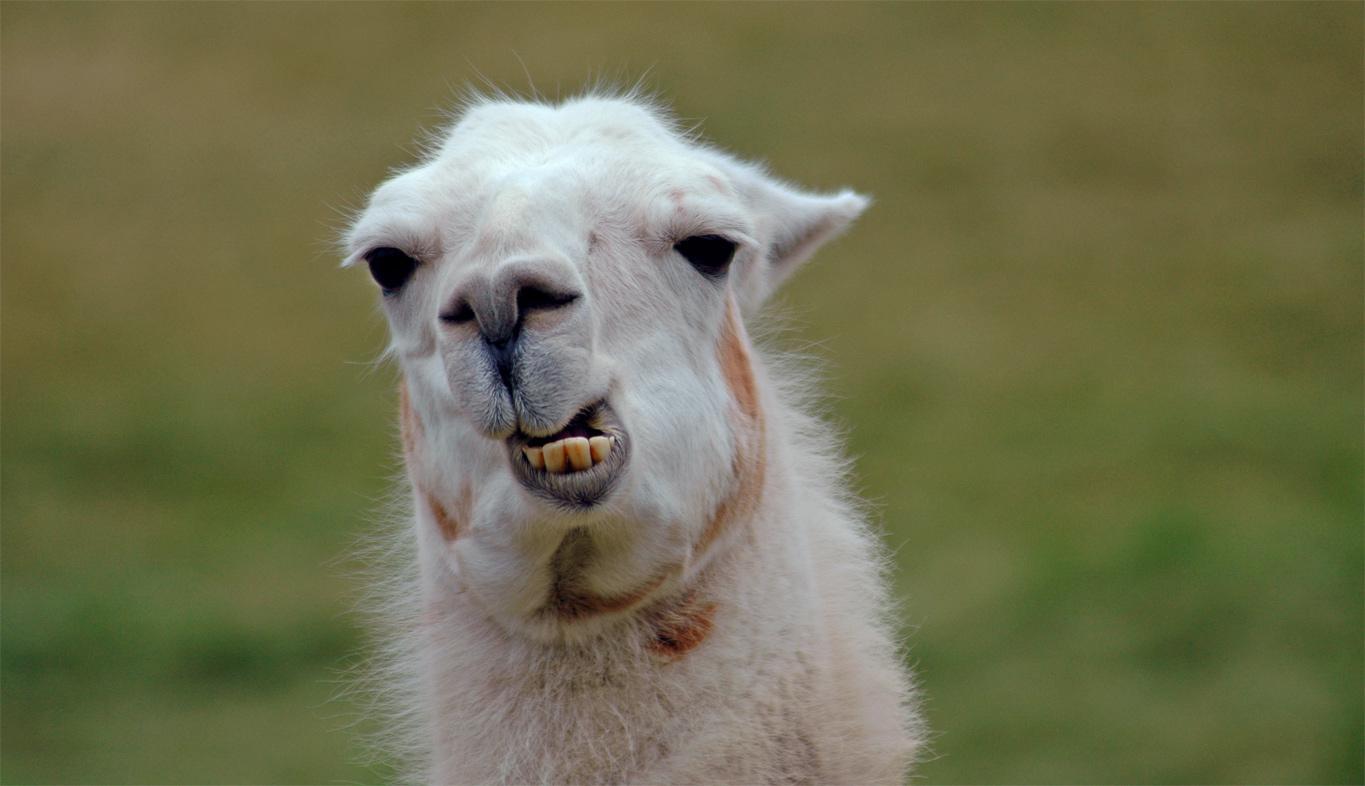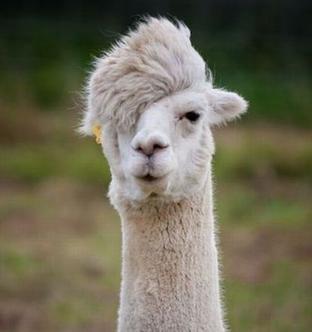The first image is the image on the left, the second image is the image on the right. Evaluate the accuracy of this statement regarding the images: "One image shows one dark-eyed white llama, which faces forward and has a partly open mouth revealing several yellow teeth.". Is it true? Answer yes or no. Yes. The first image is the image on the left, the second image is the image on the right. Examine the images to the left and right. Is the description "There are two llamas in total." accurate? Answer yes or no. Yes. 